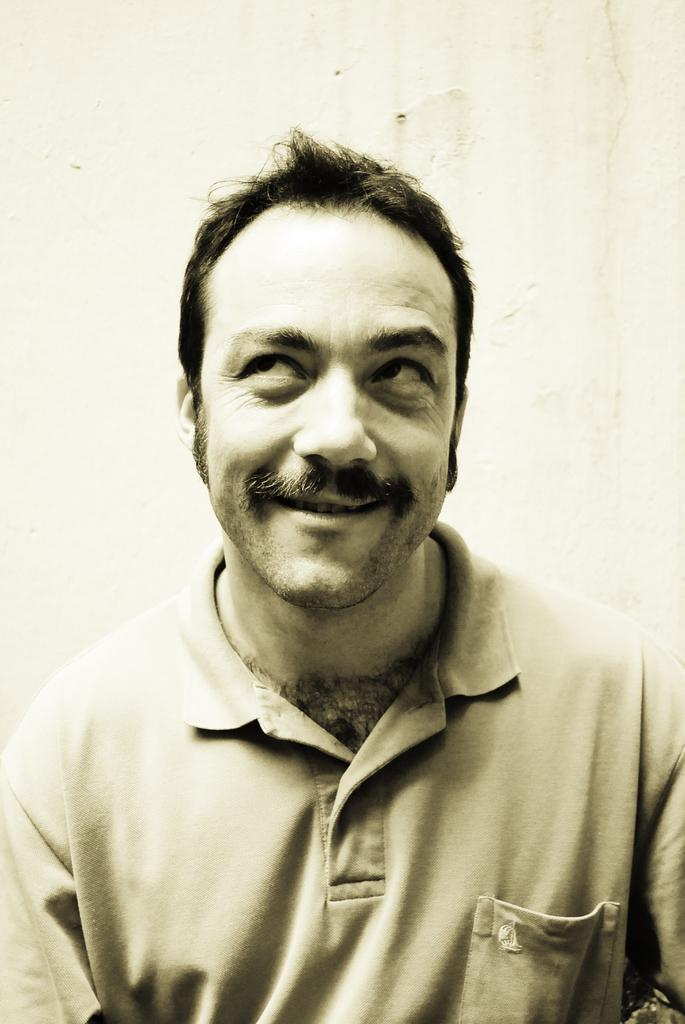What is the color scheme of the image? The image is black and white. Who is present in the image? There is a man in the image. What is the man's facial expression? The man has a smiling face. What can be seen in the background of the image? There is a white wall in the background of the image. What type of popcorn is being served on the border of the image? There is no popcorn or border present in the image; it is a black and white image of a man with a smiling face in front of a white wall. 